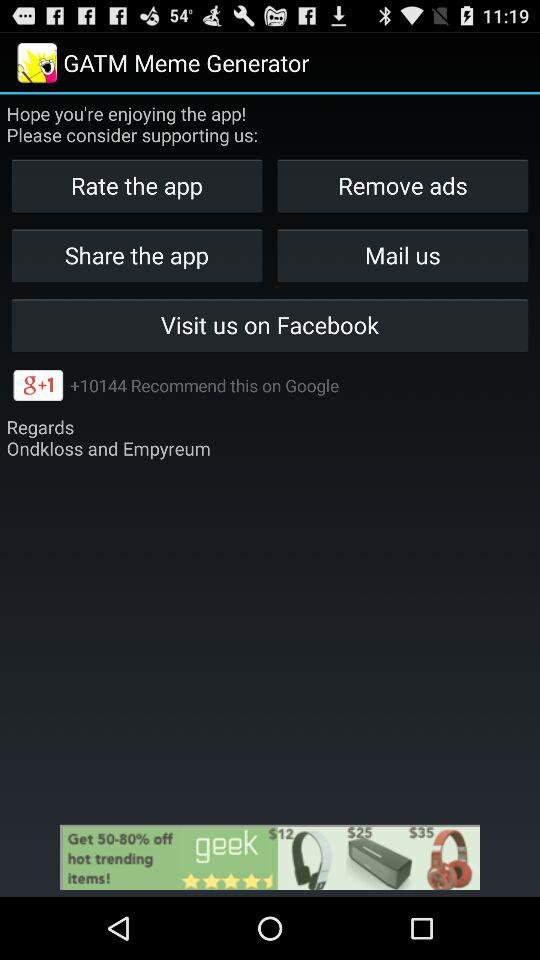How many recommendations are received on "Google"? There are more than 10144 recommendations received on "Google". 